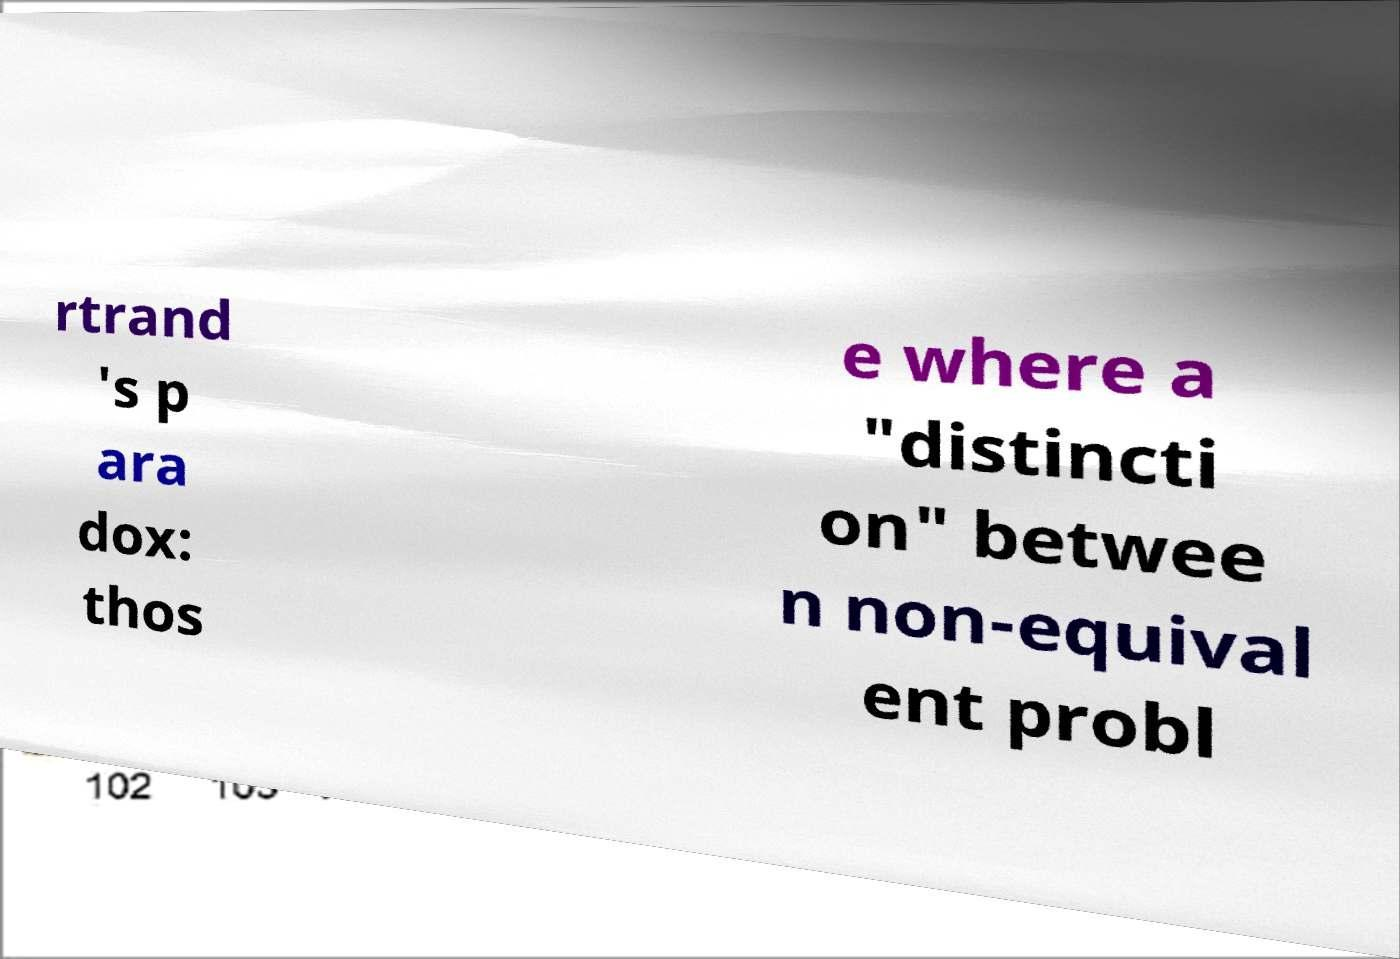Can you read and provide the text displayed in the image?This photo seems to have some interesting text. Can you extract and type it out for me? rtrand 's p ara dox: thos e where a "distincti on" betwee n non-equival ent probl 